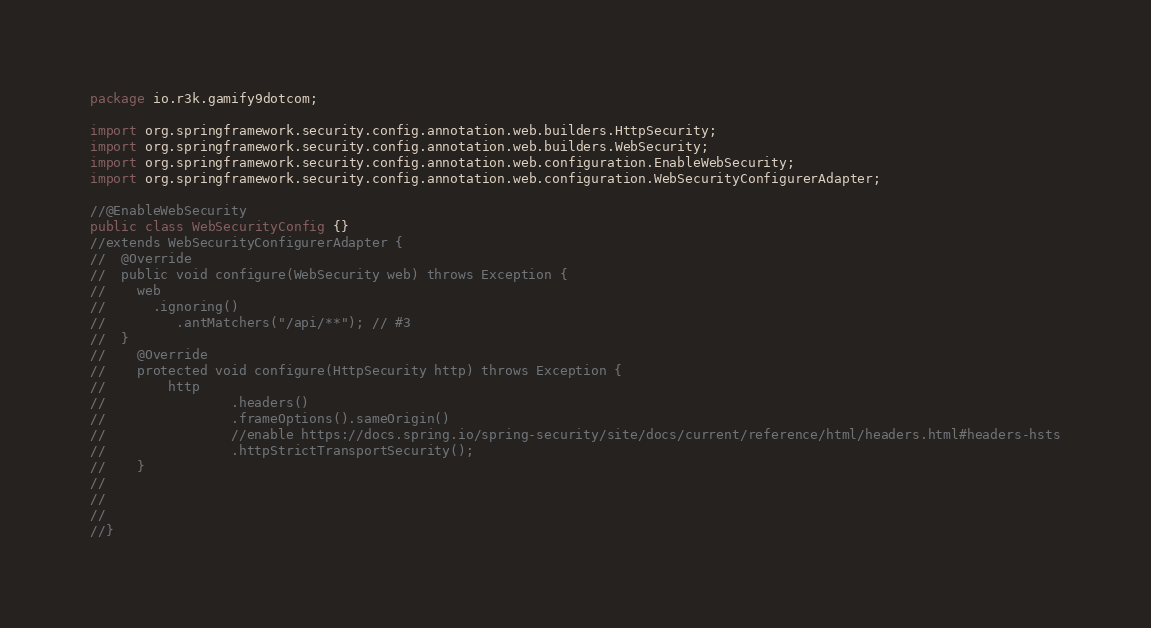Convert code to text. <code><loc_0><loc_0><loc_500><loc_500><_Java_>package io.r3k.gamify9dotcom;

import org.springframework.security.config.annotation.web.builders.HttpSecurity;
import org.springframework.security.config.annotation.web.builders.WebSecurity;
import org.springframework.security.config.annotation.web.configuration.EnableWebSecurity;
import org.springframework.security.config.annotation.web.configuration.WebSecurityConfigurerAdapter;

//@EnableWebSecurity
public class WebSecurityConfig {}
//extends WebSecurityConfigurerAdapter {
//  @Override
//  public void configure(WebSecurity web) throws Exception {
//    web
//      .ignoring()
//         .antMatchers("/api/**"); // #3
//  }
//    @Override
//    protected void configure(HttpSecurity http) throws Exception {
//        http
//                .headers()
//                .frameOptions().sameOrigin()
//                //enable https://docs.spring.io/spring-security/site/docs/current/reference/html/headers.html#headers-hsts
//                .httpStrictTransportSecurity();
//    }
//    
//    
//    
//}
</code> 